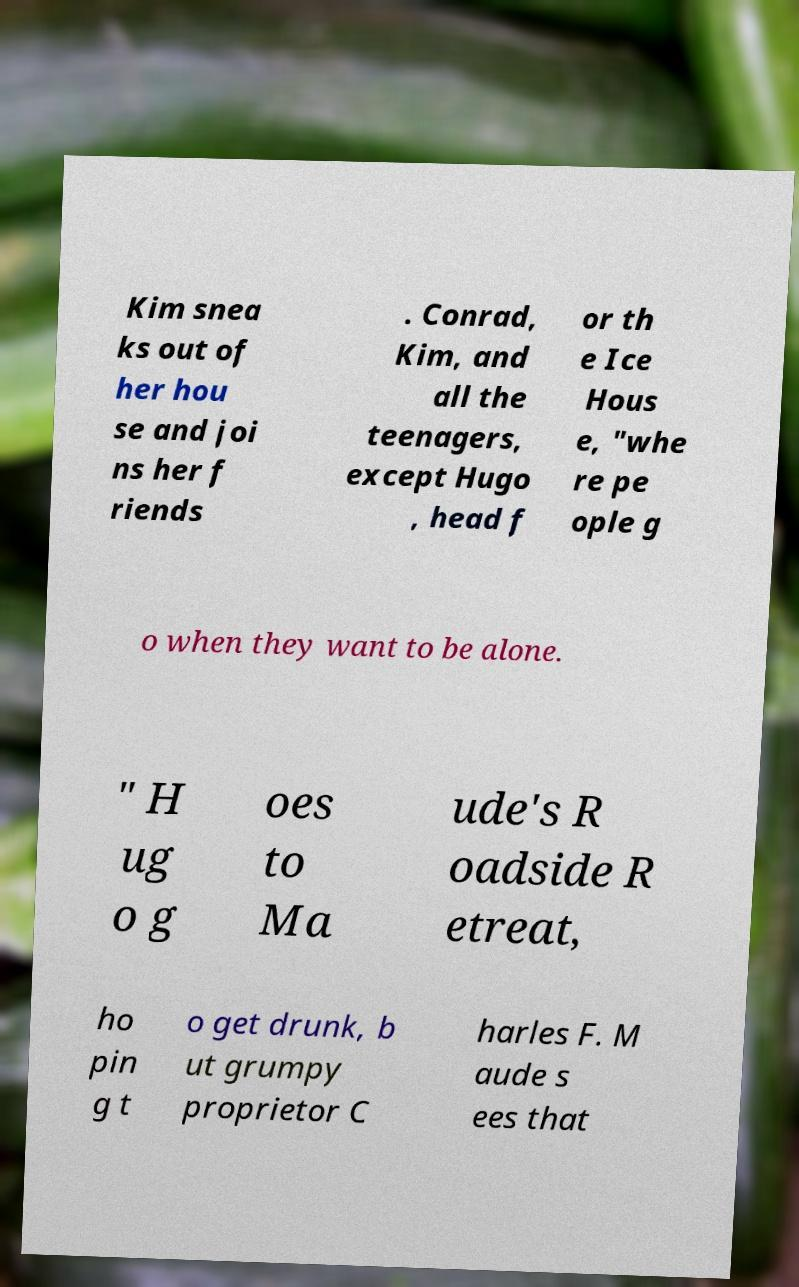Could you assist in decoding the text presented in this image and type it out clearly? Kim snea ks out of her hou se and joi ns her f riends . Conrad, Kim, and all the teenagers, except Hugo , head f or th e Ice Hous e, "whe re pe ople g o when they want to be alone. " H ug o g oes to Ma ude's R oadside R etreat, ho pin g t o get drunk, b ut grumpy proprietor C harles F. M aude s ees that 